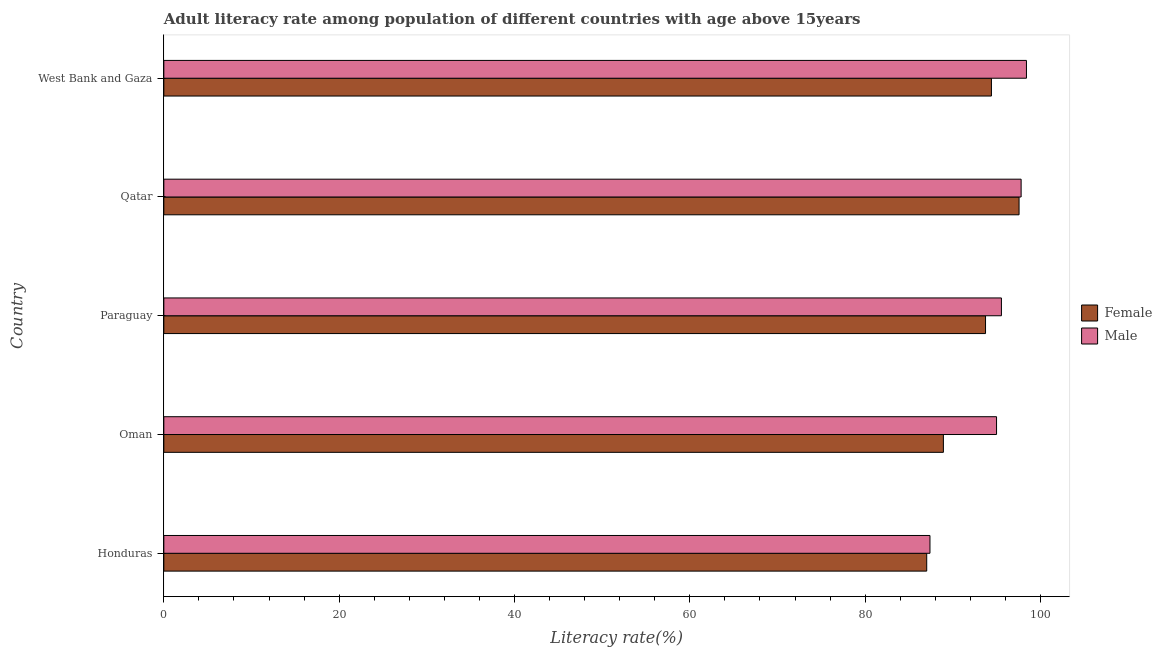How many different coloured bars are there?
Keep it short and to the point. 2. Are the number of bars per tick equal to the number of legend labels?
Keep it short and to the point. Yes. How many bars are there on the 1st tick from the top?
Offer a very short reply. 2. How many bars are there on the 2nd tick from the bottom?
Provide a succinct answer. 2. What is the label of the 4th group of bars from the top?
Your response must be concise. Oman. What is the male adult literacy rate in Honduras?
Give a very brief answer. 87.4. Across all countries, what is the maximum female adult literacy rate?
Provide a succinct answer. 97.56. Across all countries, what is the minimum male adult literacy rate?
Provide a short and direct response. 87.4. In which country was the female adult literacy rate maximum?
Your answer should be compact. Qatar. In which country was the male adult literacy rate minimum?
Ensure brevity in your answer.  Honduras. What is the total male adult literacy rate in the graph?
Your answer should be very brief. 474.13. What is the difference between the male adult literacy rate in Honduras and that in Paraguay?
Your response must be concise. -8.15. What is the difference between the female adult literacy rate in Honduras and the male adult literacy rate in Qatar?
Your answer should be compact. -10.77. What is the average female adult literacy rate per country?
Provide a short and direct response. 92.33. What is the difference between the male adult literacy rate and female adult literacy rate in Oman?
Keep it short and to the point. 6.06. In how many countries, is the male adult literacy rate greater than 60 %?
Offer a terse response. 5. What is the ratio of the female adult literacy rate in Oman to that in Qatar?
Provide a succinct answer. 0.91. What is the difference between the highest and the second highest male adult literacy rate?
Offer a terse response. 0.61. What is the difference between the highest and the lowest male adult literacy rate?
Your answer should be very brief. 11.01. Is the sum of the male adult literacy rate in Paraguay and Qatar greater than the maximum female adult literacy rate across all countries?
Provide a short and direct response. Yes. What does the 1st bar from the bottom in Oman represents?
Offer a terse response. Female. How many countries are there in the graph?
Provide a short and direct response. 5. What is the difference between two consecutive major ticks on the X-axis?
Ensure brevity in your answer.  20. Where does the legend appear in the graph?
Provide a short and direct response. Center right. How many legend labels are there?
Offer a very short reply. 2. What is the title of the graph?
Your response must be concise. Adult literacy rate among population of different countries with age above 15years. What is the label or title of the X-axis?
Your response must be concise. Literacy rate(%). What is the label or title of the Y-axis?
Your answer should be compact. Country. What is the Literacy rate(%) of Female in Honduras?
Provide a succinct answer. 87.03. What is the Literacy rate(%) in Male in Honduras?
Keep it short and to the point. 87.4. What is the Literacy rate(%) in Female in Oman?
Your response must be concise. 88.93. What is the Literacy rate(%) in Male in Oman?
Offer a terse response. 94.99. What is the Literacy rate(%) in Female in Paraguay?
Make the answer very short. 93.73. What is the Literacy rate(%) of Male in Paraguay?
Offer a terse response. 95.55. What is the Literacy rate(%) of Female in Qatar?
Give a very brief answer. 97.56. What is the Literacy rate(%) of Male in Qatar?
Keep it short and to the point. 97.79. What is the Literacy rate(%) in Female in West Bank and Gaza?
Provide a succinct answer. 94.41. What is the Literacy rate(%) in Male in West Bank and Gaza?
Your answer should be very brief. 98.4. Across all countries, what is the maximum Literacy rate(%) in Female?
Provide a short and direct response. 97.56. Across all countries, what is the maximum Literacy rate(%) in Male?
Make the answer very short. 98.4. Across all countries, what is the minimum Literacy rate(%) in Female?
Offer a very short reply. 87.03. Across all countries, what is the minimum Literacy rate(%) of Male?
Your response must be concise. 87.4. What is the total Literacy rate(%) in Female in the graph?
Provide a short and direct response. 461.65. What is the total Literacy rate(%) in Male in the graph?
Give a very brief answer. 474.13. What is the difference between the Literacy rate(%) of Female in Honduras and that in Oman?
Offer a very short reply. -1.9. What is the difference between the Literacy rate(%) in Male in Honduras and that in Oman?
Ensure brevity in your answer.  -7.59. What is the difference between the Literacy rate(%) of Female in Honduras and that in Paraguay?
Give a very brief answer. -6.71. What is the difference between the Literacy rate(%) of Male in Honduras and that in Paraguay?
Offer a very short reply. -8.15. What is the difference between the Literacy rate(%) in Female in Honduras and that in Qatar?
Provide a short and direct response. -10.53. What is the difference between the Literacy rate(%) in Male in Honduras and that in Qatar?
Your response must be concise. -10.4. What is the difference between the Literacy rate(%) of Female in Honduras and that in West Bank and Gaza?
Your answer should be compact. -7.38. What is the difference between the Literacy rate(%) of Male in Honduras and that in West Bank and Gaza?
Give a very brief answer. -11.01. What is the difference between the Literacy rate(%) in Female in Oman and that in Paraguay?
Provide a succinct answer. -4.81. What is the difference between the Literacy rate(%) of Male in Oman and that in Paraguay?
Give a very brief answer. -0.56. What is the difference between the Literacy rate(%) in Female in Oman and that in Qatar?
Keep it short and to the point. -8.63. What is the difference between the Literacy rate(%) of Male in Oman and that in Qatar?
Offer a terse response. -2.8. What is the difference between the Literacy rate(%) in Female in Oman and that in West Bank and Gaza?
Provide a short and direct response. -5.48. What is the difference between the Literacy rate(%) of Male in Oman and that in West Bank and Gaza?
Keep it short and to the point. -3.41. What is the difference between the Literacy rate(%) in Female in Paraguay and that in Qatar?
Make the answer very short. -3.82. What is the difference between the Literacy rate(%) in Male in Paraguay and that in Qatar?
Provide a succinct answer. -2.25. What is the difference between the Literacy rate(%) of Female in Paraguay and that in West Bank and Gaza?
Offer a terse response. -0.67. What is the difference between the Literacy rate(%) of Male in Paraguay and that in West Bank and Gaza?
Your answer should be very brief. -2.86. What is the difference between the Literacy rate(%) in Female in Qatar and that in West Bank and Gaza?
Give a very brief answer. 3.15. What is the difference between the Literacy rate(%) of Male in Qatar and that in West Bank and Gaza?
Ensure brevity in your answer.  -0.61. What is the difference between the Literacy rate(%) in Female in Honduras and the Literacy rate(%) in Male in Oman?
Your answer should be very brief. -7.96. What is the difference between the Literacy rate(%) in Female in Honduras and the Literacy rate(%) in Male in Paraguay?
Give a very brief answer. -8.52. What is the difference between the Literacy rate(%) of Female in Honduras and the Literacy rate(%) of Male in Qatar?
Make the answer very short. -10.77. What is the difference between the Literacy rate(%) in Female in Honduras and the Literacy rate(%) in Male in West Bank and Gaza?
Your response must be concise. -11.38. What is the difference between the Literacy rate(%) of Female in Oman and the Literacy rate(%) of Male in Paraguay?
Your answer should be very brief. -6.62. What is the difference between the Literacy rate(%) of Female in Oman and the Literacy rate(%) of Male in Qatar?
Provide a succinct answer. -8.87. What is the difference between the Literacy rate(%) in Female in Oman and the Literacy rate(%) in Male in West Bank and Gaza?
Your answer should be very brief. -9.48. What is the difference between the Literacy rate(%) in Female in Paraguay and the Literacy rate(%) in Male in Qatar?
Your answer should be compact. -4.06. What is the difference between the Literacy rate(%) of Female in Paraguay and the Literacy rate(%) of Male in West Bank and Gaza?
Make the answer very short. -4.67. What is the difference between the Literacy rate(%) of Female in Qatar and the Literacy rate(%) of Male in West Bank and Gaza?
Your answer should be very brief. -0.84. What is the average Literacy rate(%) of Female per country?
Your answer should be compact. 92.33. What is the average Literacy rate(%) in Male per country?
Your answer should be compact. 94.83. What is the difference between the Literacy rate(%) of Female and Literacy rate(%) of Male in Honduras?
Offer a very short reply. -0.37. What is the difference between the Literacy rate(%) in Female and Literacy rate(%) in Male in Oman?
Make the answer very short. -6.06. What is the difference between the Literacy rate(%) of Female and Literacy rate(%) of Male in Paraguay?
Offer a very short reply. -1.81. What is the difference between the Literacy rate(%) in Female and Literacy rate(%) in Male in Qatar?
Your response must be concise. -0.24. What is the difference between the Literacy rate(%) in Female and Literacy rate(%) in Male in West Bank and Gaza?
Your answer should be very brief. -4. What is the ratio of the Literacy rate(%) of Female in Honduras to that in Oman?
Make the answer very short. 0.98. What is the ratio of the Literacy rate(%) in Female in Honduras to that in Paraguay?
Keep it short and to the point. 0.93. What is the ratio of the Literacy rate(%) of Male in Honduras to that in Paraguay?
Keep it short and to the point. 0.91. What is the ratio of the Literacy rate(%) of Female in Honduras to that in Qatar?
Make the answer very short. 0.89. What is the ratio of the Literacy rate(%) in Male in Honduras to that in Qatar?
Your answer should be very brief. 0.89. What is the ratio of the Literacy rate(%) of Female in Honduras to that in West Bank and Gaza?
Your response must be concise. 0.92. What is the ratio of the Literacy rate(%) of Male in Honduras to that in West Bank and Gaza?
Make the answer very short. 0.89. What is the ratio of the Literacy rate(%) in Female in Oman to that in Paraguay?
Offer a very short reply. 0.95. What is the ratio of the Literacy rate(%) of Male in Oman to that in Paraguay?
Your response must be concise. 0.99. What is the ratio of the Literacy rate(%) of Female in Oman to that in Qatar?
Your answer should be very brief. 0.91. What is the ratio of the Literacy rate(%) in Male in Oman to that in Qatar?
Your answer should be compact. 0.97. What is the ratio of the Literacy rate(%) in Female in Oman to that in West Bank and Gaza?
Offer a terse response. 0.94. What is the ratio of the Literacy rate(%) of Male in Oman to that in West Bank and Gaza?
Give a very brief answer. 0.97. What is the ratio of the Literacy rate(%) of Female in Paraguay to that in Qatar?
Offer a terse response. 0.96. What is the ratio of the Literacy rate(%) of Male in Paraguay to that in Qatar?
Provide a short and direct response. 0.98. What is the ratio of the Literacy rate(%) of Male in Paraguay to that in West Bank and Gaza?
Offer a terse response. 0.97. What is the ratio of the Literacy rate(%) in Female in Qatar to that in West Bank and Gaza?
Offer a very short reply. 1.03. What is the ratio of the Literacy rate(%) in Male in Qatar to that in West Bank and Gaza?
Your response must be concise. 0.99. What is the difference between the highest and the second highest Literacy rate(%) in Female?
Your answer should be compact. 3.15. What is the difference between the highest and the second highest Literacy rate(%) in Male?
Your response must be concise. 0.61. What is the difference between the highest and the lowest Literacy rate(%) of Female?
Offer a very short reply. 10.53. What is the difference between the highest and the lowest Literacy rate(%) in Male?
Your answer should be very brief. 11.01. 